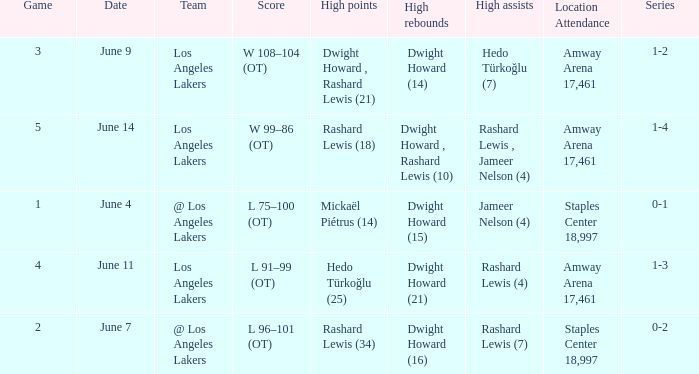What is Team, when High Assists is "Rashard Lewis (4)"? Los Angeles Lakers. 